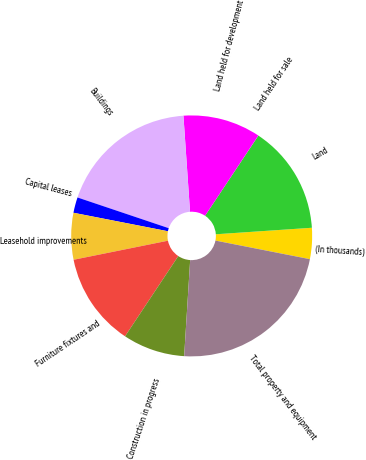<chart> <loc_0><loc_0><loc_500><loc_500><pie_chart><fcel>(In thousands)<fcel>Land<fcel>Land held for sale<fcel>Land held for development<fcel>Buildings<fcel>Capital leases<fcel>Leasehold improvements<fcel>Furniture fixtures and<fcel>Construction in progress<fcel>Total property and equipment<nl><fcel>4.17%<fcel>14.58%<fcel>0.01%<fcel>10.42%<fcel>18.74%<fcel>2.09%<fcel>6.25%<fcel>12.5%<fcel>8.33%<fcel>22.9%<nl></chart> 